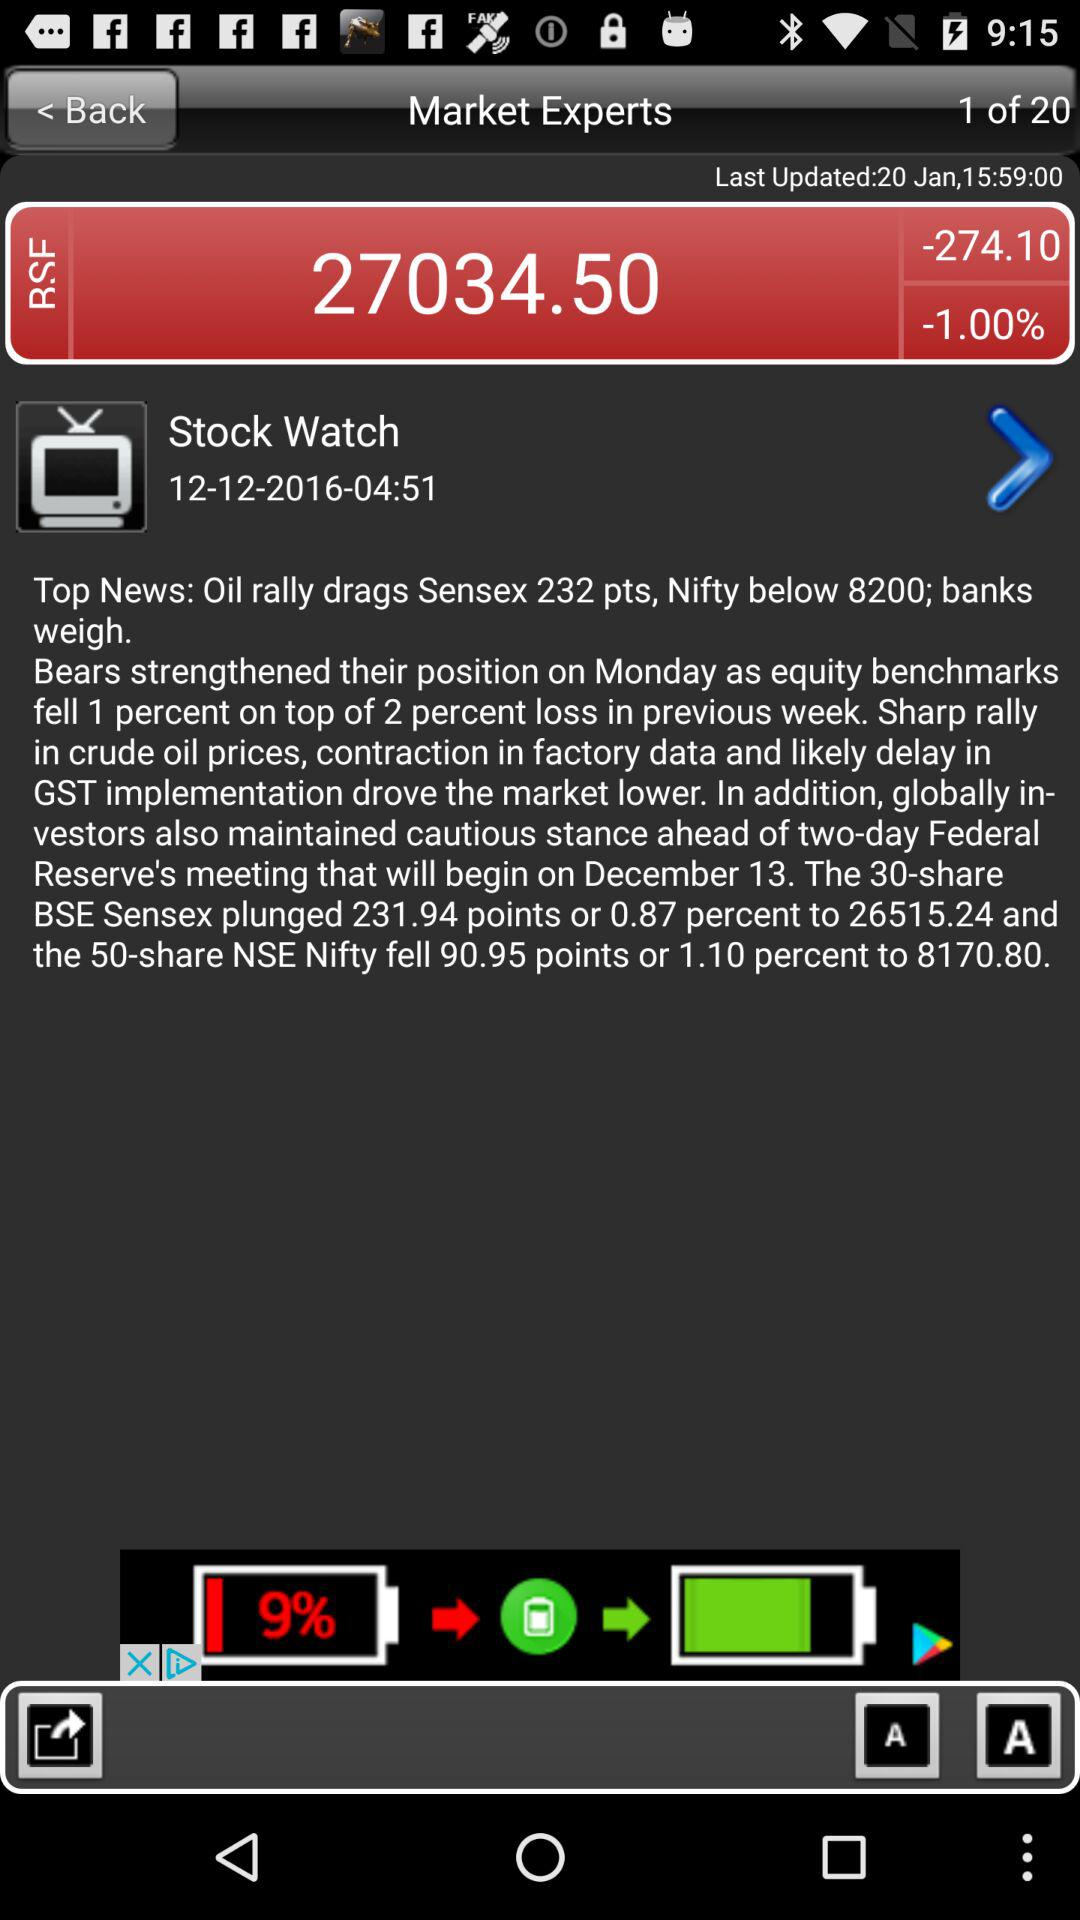Which page is the person on? The person is on the first page. 